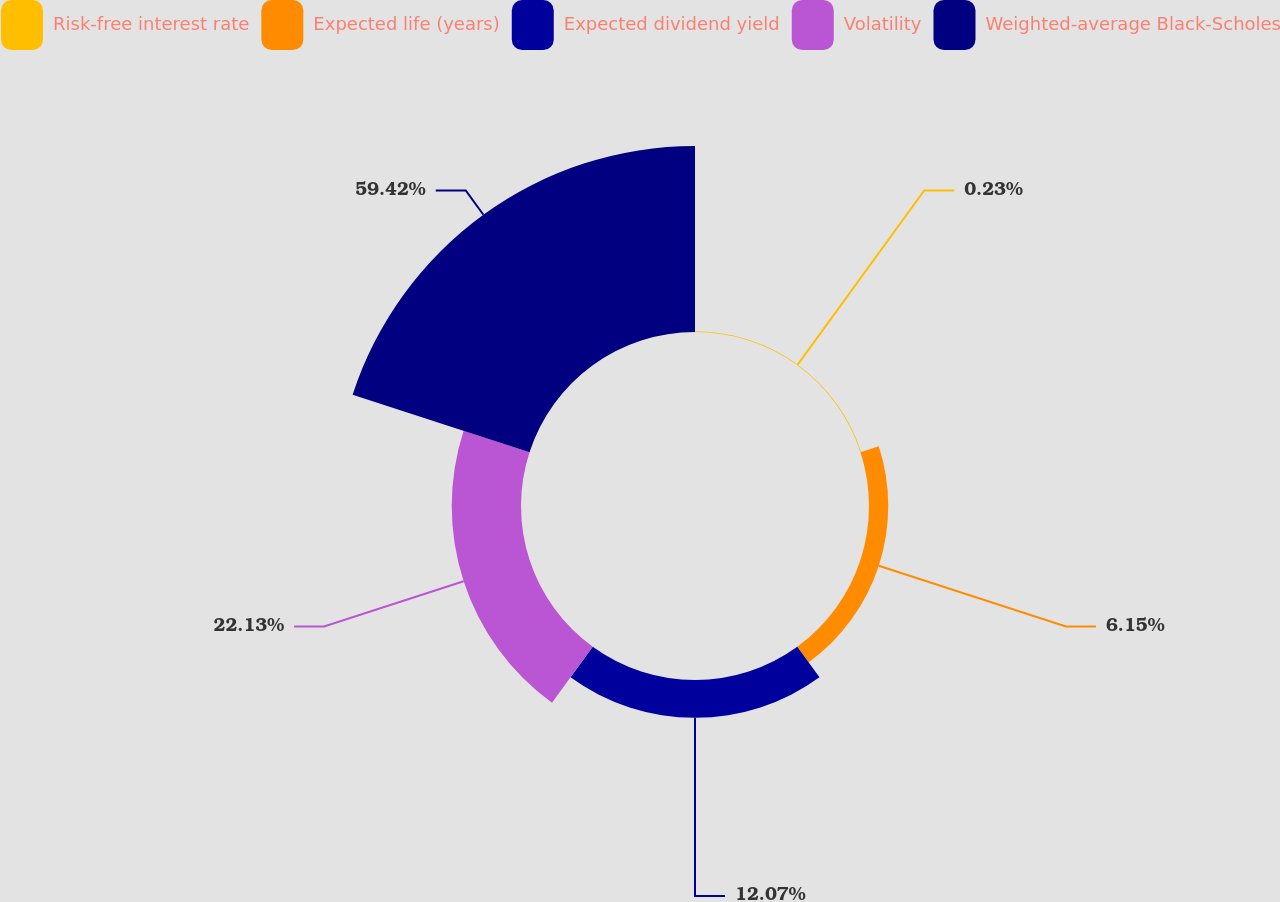Convert chart. <chart><loc_0><loc_0><loc_500><loc_500><pie_chart><fcel>Risk-free interest rate<fcel>Expected life (years)<fcel>Expected dividend yield<fcel>Volatility<fcel>Weighted-average Black-Scholes<nl><fcel>0.23%<fcel>6.15%<fcel>12.07%<fcel>22.13%<fcel>59.42%<nl></chart> 